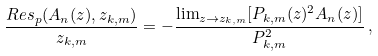Convert formula to latex. <formula><loc_0><loc_0><loc_500><loc_500>\frac { R e s _ { p } ( A _ { n } ( z ) , z _ { k , m } ) } { z _ { k , m } } = - \frac { \lim _ { z \rightarrow z _ { k , m } } [ P _ { k , m } ( z ) ^ { 2 } A _ { n } ( z ) ] } { P _ { k , m } ^ { 2 } } \, ,</formula> 